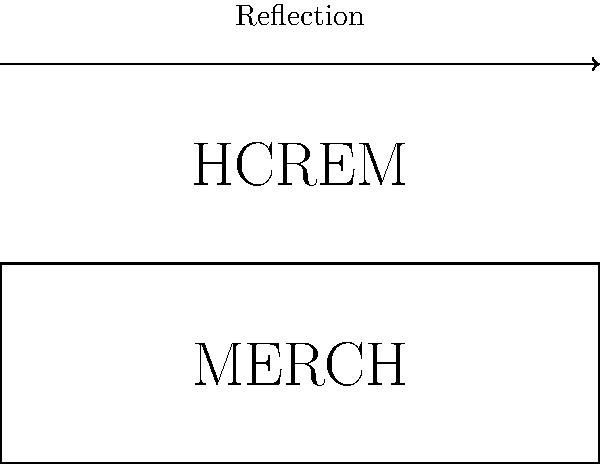As an e-commerce representative handling merchandise inquiries, you need to explain the process of creating mirror-image text for printing on transparent products. If the word "MERCH" needs to be printed so that it appears correctly when viewed through the transparent material, how should it be printed on the product? To create a mirror-image text for printing on transparent products, we need to apply a reflection transformation to the original text. Here's the step-by-step process:

1. Identify the axis of reflection: In this case, it's a horizontal line above the original text.

2. For each letter in "MERCH":
   a. Reflect it vertically across the axis of reflection.
   b. The top of each letter becomes the bottom, and vice versa.

3. The order of the letters remains the same (left to right), but each letter is flipped upside down.

4. The resulting text will appear as "HCREM" when printed, but will read correctly as "MERCH" when viewed through the transparent material.

This transformation can be represented mathematically as a reflection matrix:

$$ \begin{bmatrix} 1 & 0 \\ 0 & -1 \end{bmatrix} $$

This matrix flips the y-coordinate of each point in the text, creating the mirror image.
Answer: HCREM 